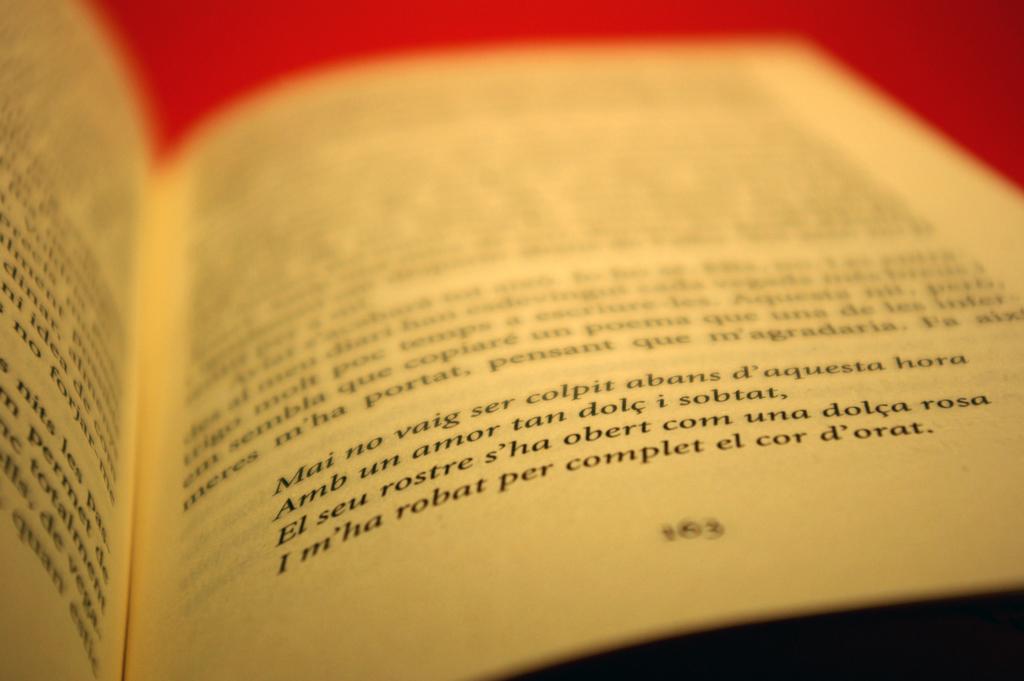What page number is the book turned to?
Give a very brief answer. 163. What is the last word on the page?
Your response must be concise. D'orat. 